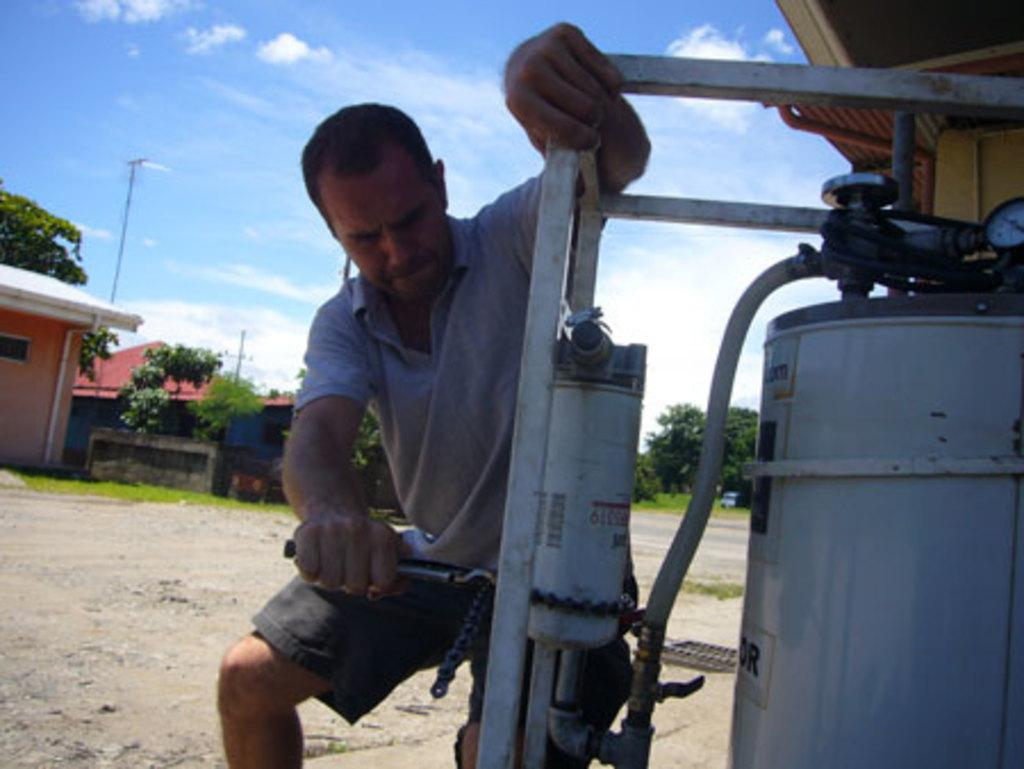What is the main subject of the image? There is a person in the image. What is the person doing in the image? The person is operating a machine. What can be seen in the background of the image? There are trees, houses, and the sky visible in the background of the image. What type of veil is the person wearing while operating the machine in the image? There is no veil present in the image; the person is operating a machine without any visible headwear. 